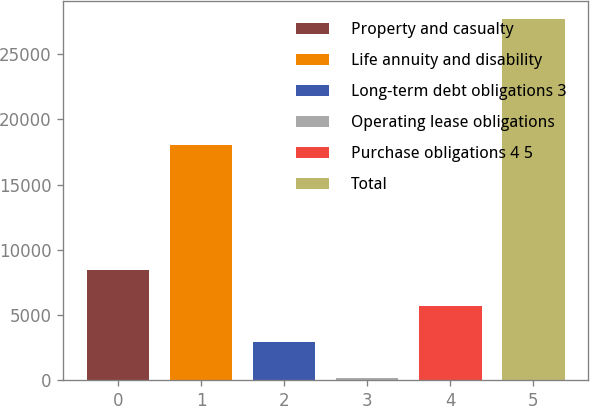<chart> <loc_0><loc_0><loc_500><loc_500><bar_chart><fcel>Property and casualty<fcel>Life annuity and disability<fcel>Long-term debt obligations 3<fcel>Operating lease obligations<fcel>Purchase obligations 4 5<fcel>Total<nl><fcel>8441.2<fcel>18037<fcel>2930.4<fcel>175<fcel>5685.8<fcel>27729<nl></chart> 